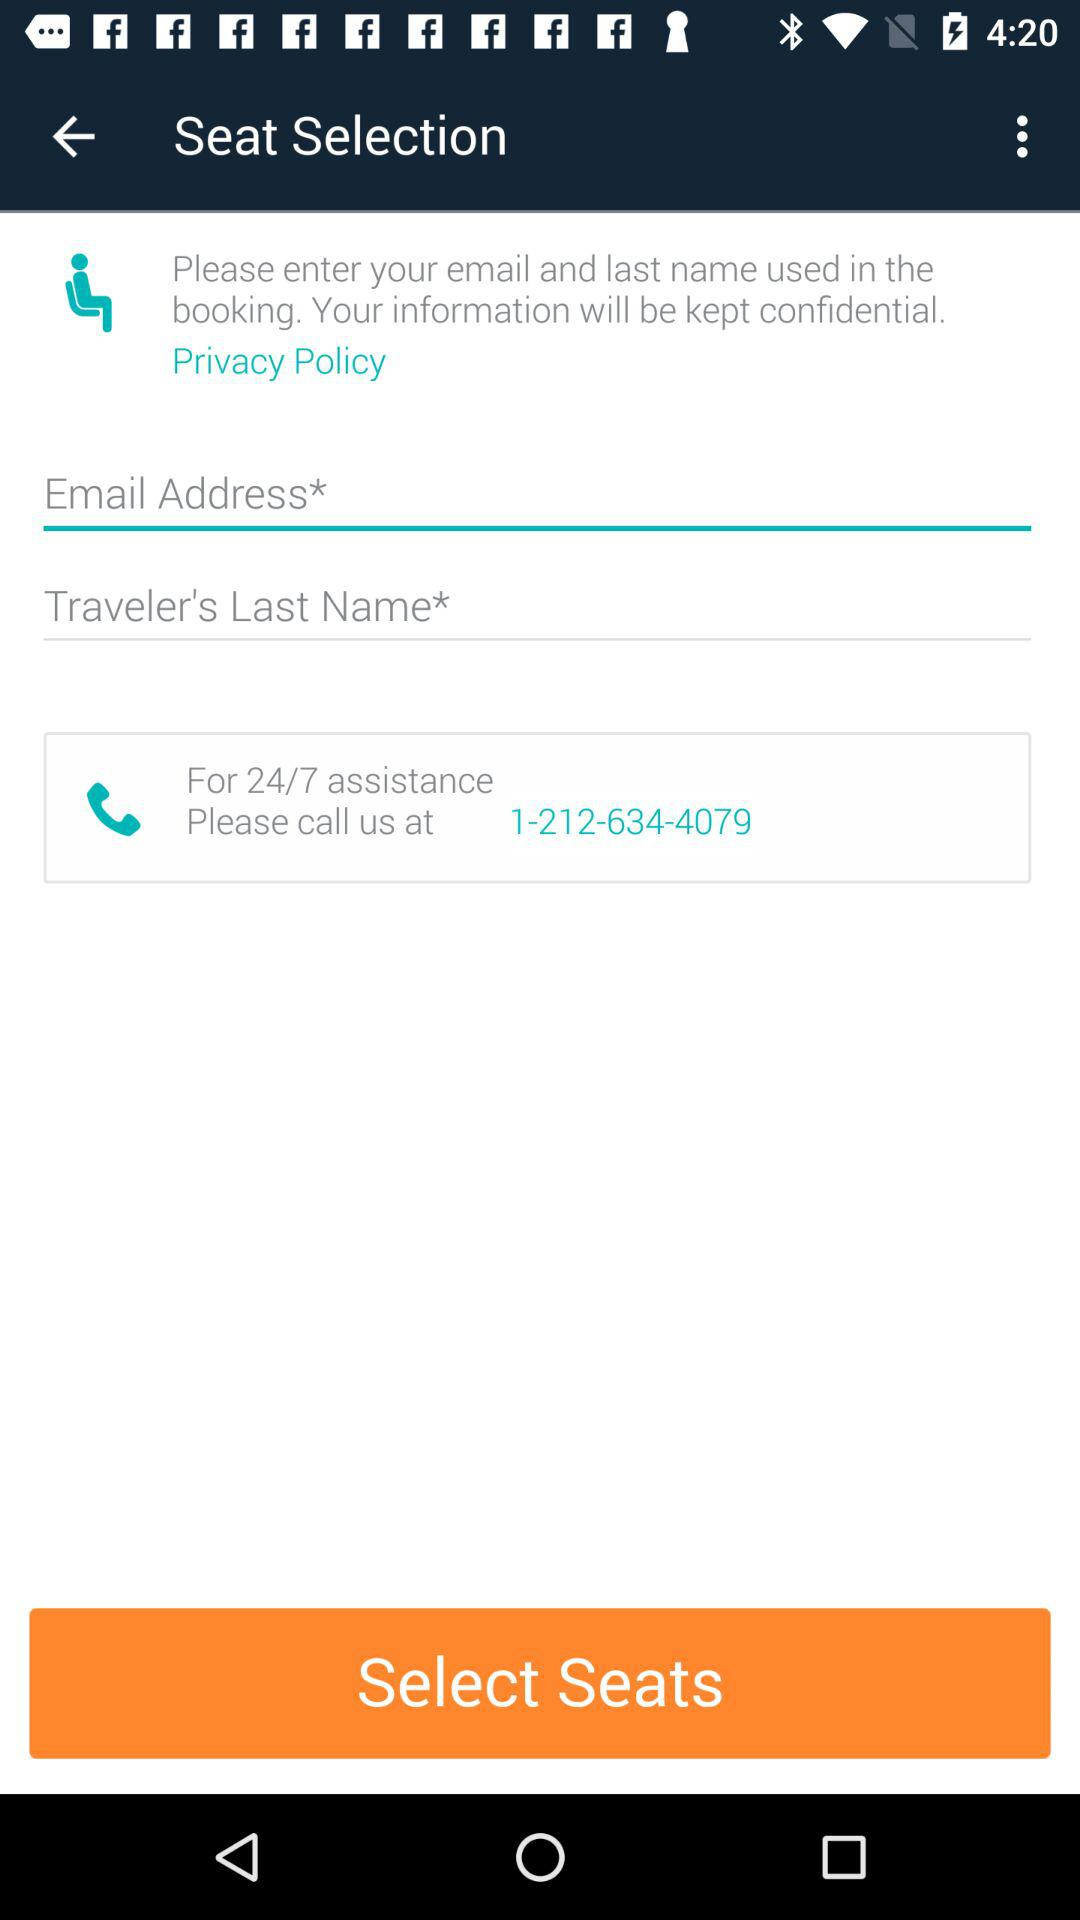Is there any indication of the next step after entering the contact information? Yes, the orange button labeled 'Select Seats' suggests that after entering the necessary contact information, the next step is to select seats for the booking. 